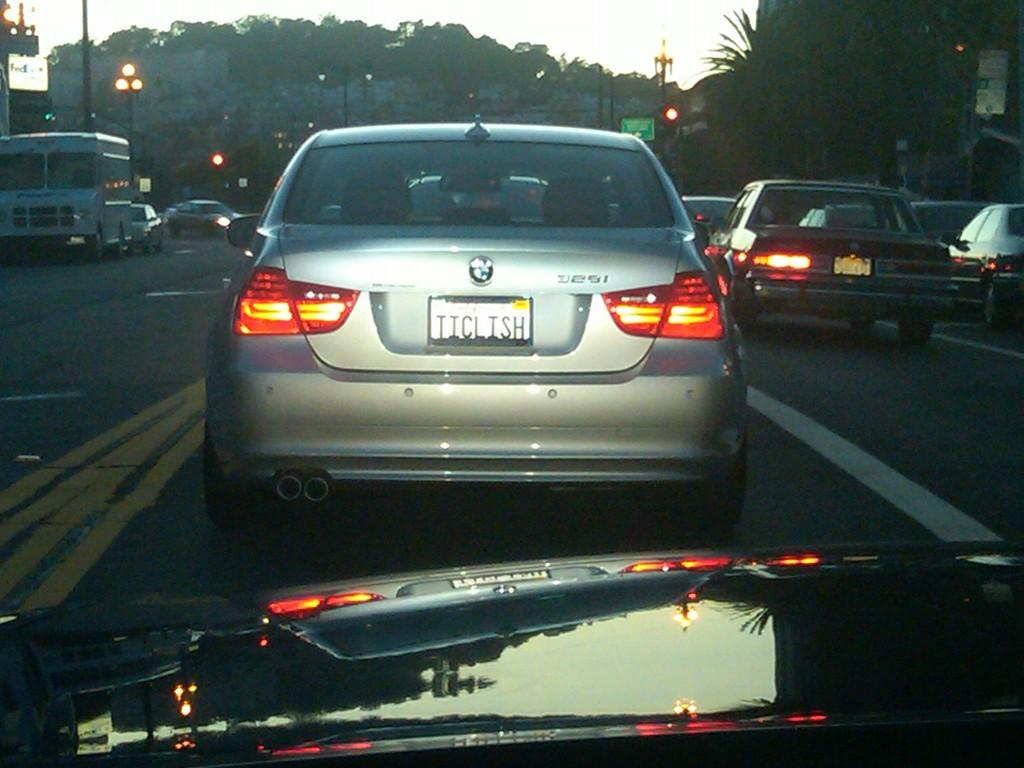<image>
Describe the image concisely. A car is following a silver BMW and a FedEx sign is visible in the background. 